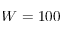<formula> <loc_0><loc_0><loc_500><loc_500>W = 1 0 0</formula> 